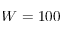<formula> <loc_0><loc_0><loc_500><loc_500>W = 1 0 0</formula> 